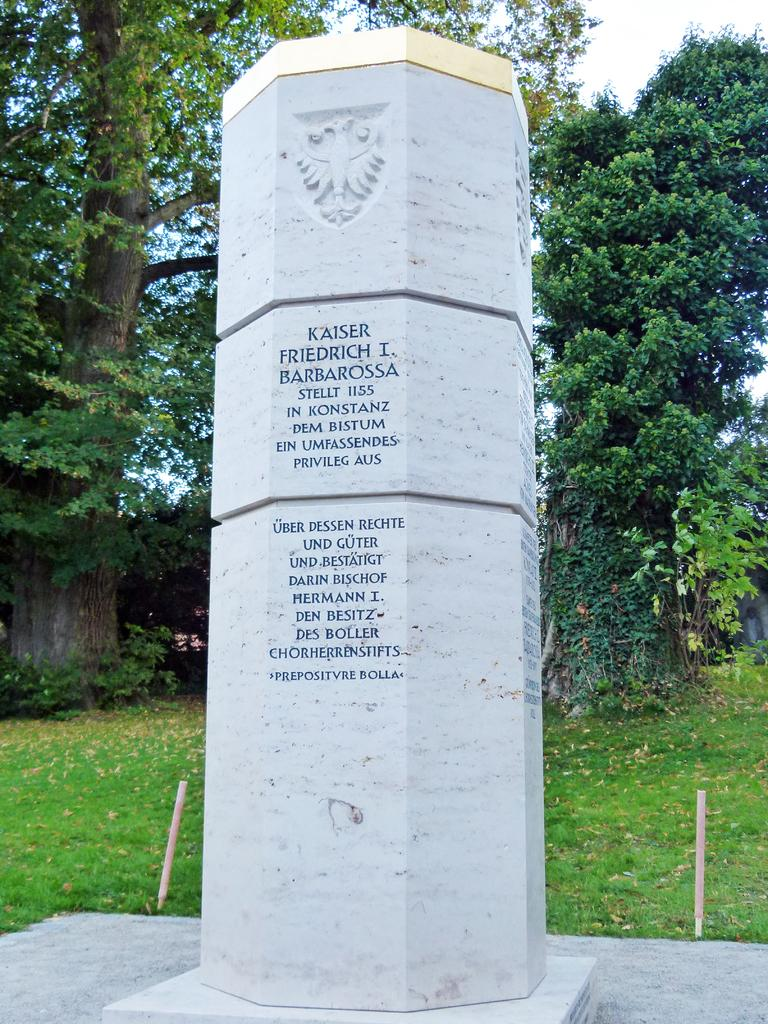What is the main structure visible in the image? There is a pillar in the image. What is on top of the pillar? There is a sculpture on the pillar. What can be found on the pillar besides the sculpture? There is text written on the pillar. What type of natural environment is depicted in the image? There is grass on the ground, trees, and plants in the image. What invention is being supported by the pillar in the image? There is no invention being supported by the pillar in the image; it is a standalone structure with a sculpture and text. Can you see any beans growing on the plants in the image? There is no mention of beans or bean plants in the image; it features grass, trees, and unspecified plants. 